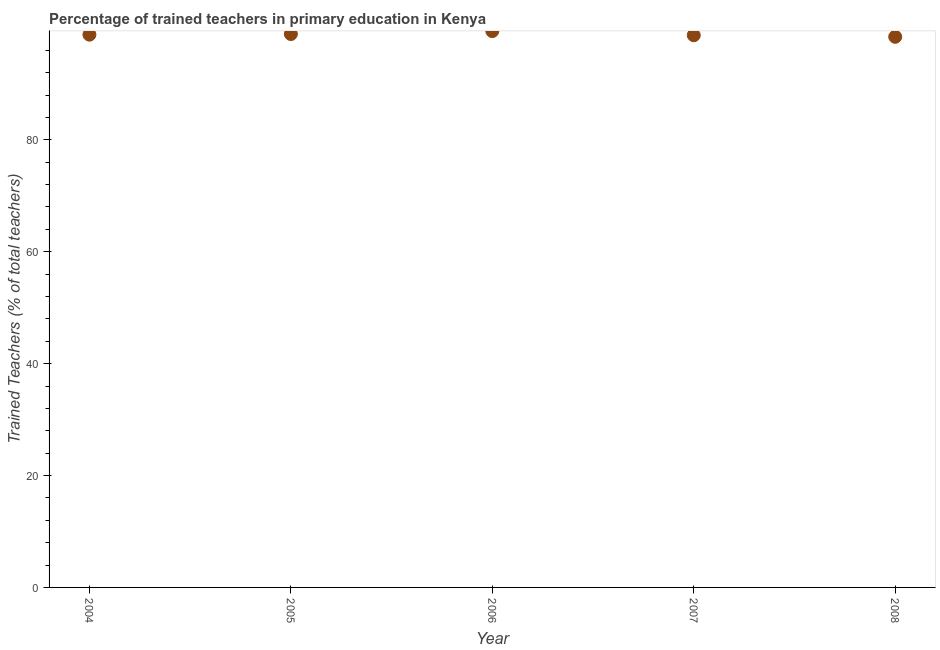What is the percentage of trained teachers in 2007?
Provide a short and direct response. 98.7. Across all years, what is the maximum percentage of trained teachers?
Keep it short and to the point. 99.43. Across all years, what is the minimum percentage of trained teachers?
Offer a terse response. 98.42. What is the sum of the percentage of trained teachers?
Your answer should be very brief. 494.26. What is the difference between the percentage of trained teachers in 2005 and 2008?
Offer a terse response. 0.5. What is the average percentage of trained teachers per year?
Make the answer very short. 98.85. What is the median percentage of trained teachers?
Give a very brief answer. 98.8. In how many years, is the percentage of trained teachers greater than 92 %?
Your response must be concise. 5. What is the ratio of the percentage of trained teachers in 2004 to that in 2006?
Give a very brief answer. 0.99. Is the percentage of trained teachers in 2004 less than that in 2005?
Offer a terse response. Yes. What is the difference between the highest and the second highest percentage of trained teachers?
Keep it short and to the point. 0.52. Is the sum of the percentage of trained teachers in 2007 and 2008 greater than the maximum percentage of trained teachers across all years?
Offer a very short reply. Yes. What is the difference between the highest and the lowest percentage of trained teachers?
Offer a very short reply. 1.02. How many dotlines are there?
Give a very brief answer. 1. How many years are there in the graph?
Your answer should be very brief. 5. What is the difference between two consecutive major ticks on the Y-axis?
Your answer should be compact. 20. Does the graph contain any zero values?
Provide a succinct answer. No. What is the title of the graph?
Make the answer very short. Percentage of trained teachers in primary education in Kenya. What is the label or title of the X-axis?
Offer a very short reply. Year. What is the label or title of the Y-axis?
Provide a short and direct response. Trained Teachers (% of total teachers). What is the Trained Teachers (% of total teachers) in 2004?
Provide a succinct answer. 98.8. What is the Trained Teachers (% of total teachers) in 2005?
Give a very brief answer. 98.91. What is the Trained Teachers (% of total teachers) in 2006?
Your answer should be compact. 99.43. What is the Trained Teachers (% of total teachers) in 2007?
Provide a short and direct response. 98.7. What is the Trained Teachers (% of total teachers) in 2008?
Your answer should be very brief. 98.42. What is the difference between the Trained Teachers (% of total teachers) in 2004 and 2005?
Provide a short and direct response. -0.11. What is the difference between the Trained Teachers (% of total teachers) in 2004 and 2006?
Your answer should be compact. -0.63. What is the difference between the Trained Teachers (% of total teachers) in 2004 and 2007?
Provide a short and direct response. 0.1. What is the difference between the Trained Teachers (% of total teachers) in 2004 and 2008?
Keep it short and to the point. 0.38. What is the difference between the Trained Teachers (% of total teachers) in 2005 and 2006?
Your response must be concise. -0.52. What is the difference between the Trained Teachers (% of total teachers) in 2005 and 2007?
Keep it short and to the point. 0.22. What is the difference between the Trained Teachers (% of total teachers) in 2005 and 2008?
Give a very brief answer. 0.5. What is the difference between the Trained Teachers (% of total teachers) in 2006 and 2007?
Keep it short and to the point. 0.74. What is the difference between the Trained Teachers (% of total teachers) in 2006 and 2008?
Provide a succinct answer. 1.02. What is the difference between the Trained Teachers (% of total teachers) in 2007 and 2008?
Give a very brief answer. 0.28. What is the ratio of the Trained Teachers (% of total teachers) in 2004 to that in 2006?
Your answer should be compact. 0.99. What is the ratio of the Trained Teachers (% of total teachers) in 2004 to that in 2007?
Give a very brief answer. 1. What is the ratio of the Trained Teachers (% of total teachers) in 2005 to that in 2007?
Ensure brevity in your answer.  1. What is the ratio of the Trained Teachers (% of total teachers) in 2006 to that in 2008?
Provide a short and direct response. 1.01. 